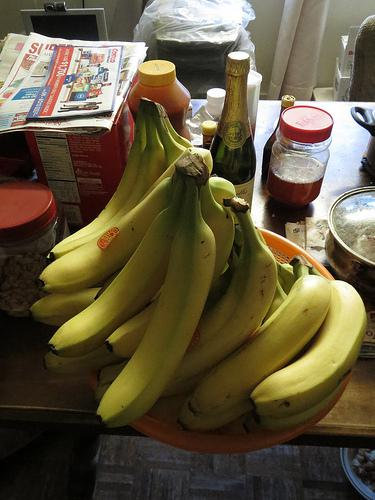Question: what are the papers on?
Choices:
A. Box.
B. The desk.
C. The floor.
D. The counter.
Answer with the letter. Answer: A Question: where are the bananas?
Choices:
A. In the fridge.
B. On the counter.
C. At the grocery store.
D. Basket.
Answer with the letter. Answer: D Question: why are the bananas there?
Choices:
A. To eat.
B. To bake with.
C. To have as a snack.
D. To display.
Answer with the letter. Answer: A Question: when are the bananas in the basket?
Choices:
A. Now.
B. Tomorrow.
C. Today.
D. Yesterday.
Answer with the letter. Answer: A Question: what color are the bananas?
Choices:
A. Green.
B. Yellow.
C. Black.
D. Gold.
Answer with the letter. Answer: B 